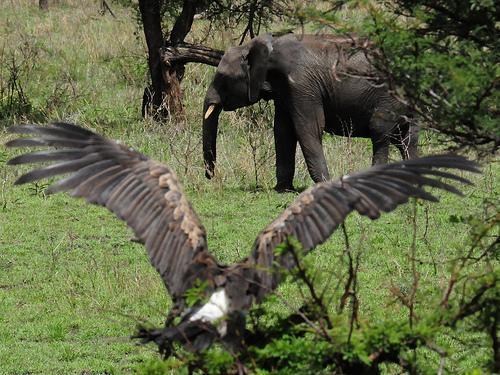How many animals are shown?
Give a very brief answer. 2. 